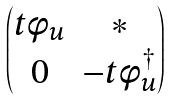<formula> <loc_0><loc_0><loc_500><loc_500>\begin{pmatrix} t \phi _ { u } & * \\ 0 & - t \phi _ { u } ^ { \dagger } \end{pmatrix}</formula> 